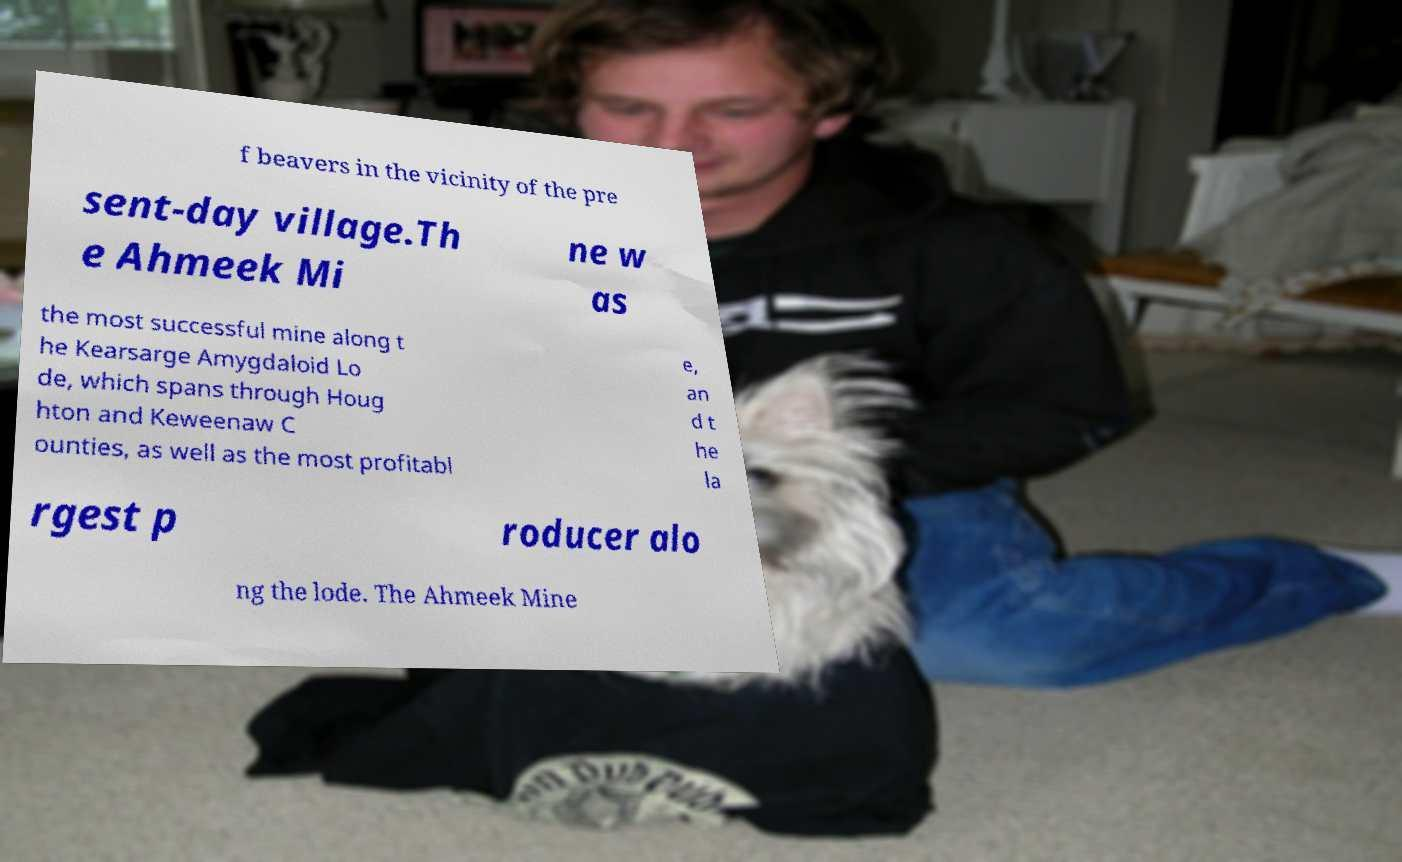I need the written content from this picture converted into text. Can you do that? f beavers in the vicinity of the pre sent-day village.Th e Ahmeek Mi ne w as the most successful mine along t he Kearsarge Amygdaloid Lo de, which spans through Houg hton and Keweenaw C ounties, as well as the most profitabl e, an d t he la rgest p roducer alo ng the lode. The Ahmeek Mine 